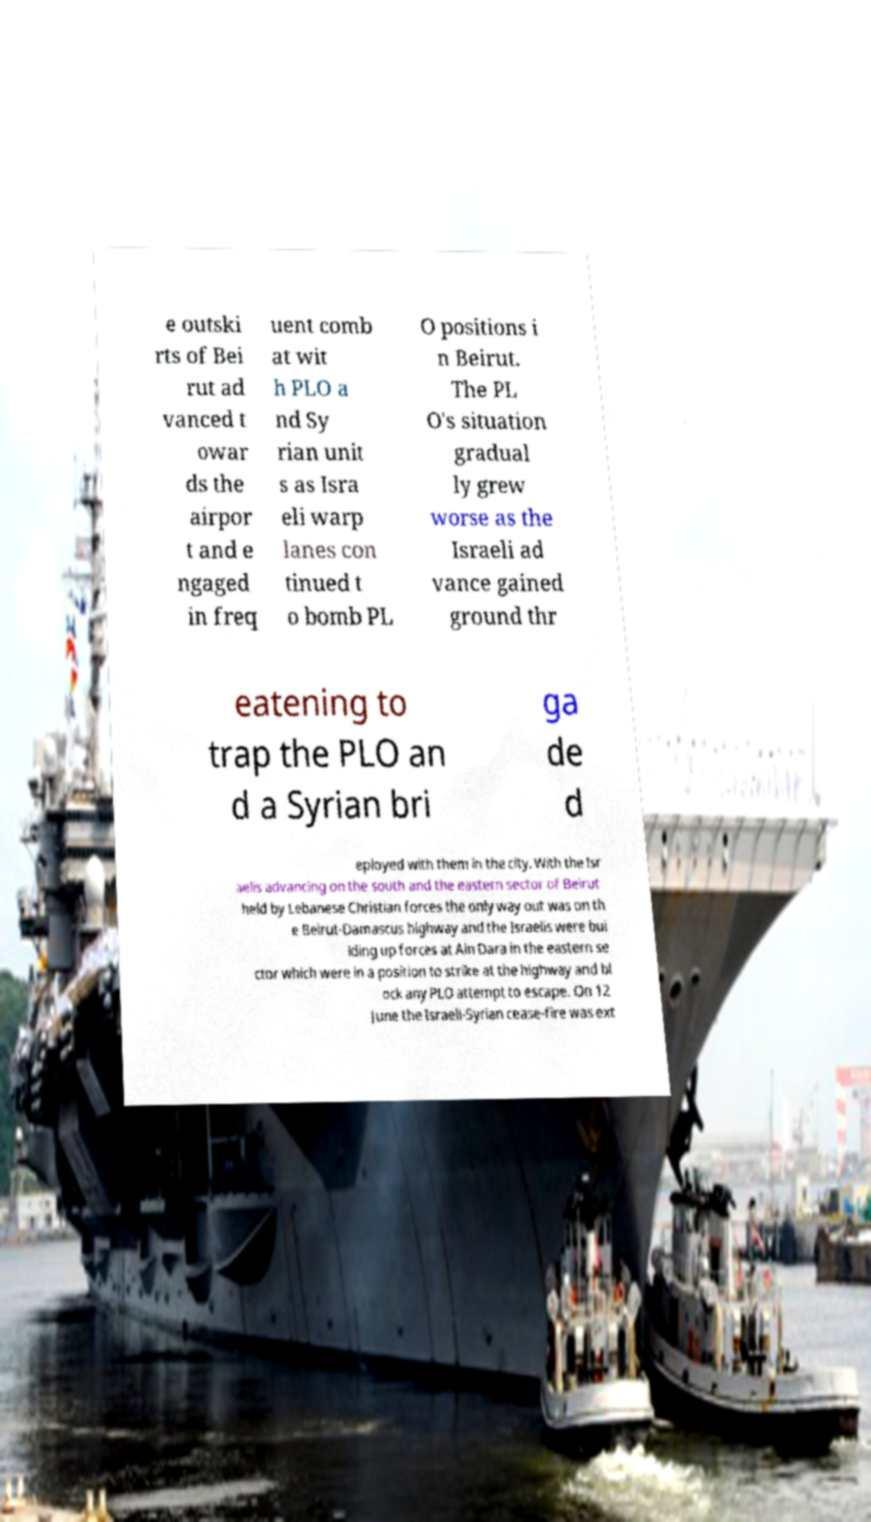Please identify and transcribe the text found in this image. e outski rts of Bei rut ad vanced t owar ds the airpor t and e ngaged in freq uent comb at wit h PLO a nd Sy rian unit s as Isra eli warp lanes con tinued t o bomb PL O positions i n Beirut. The PL O's situation gradual ly grew worse as the Israeli ad vance gained ground thr eatening to trap the PLO an d a Syrian bri ga de d eployed with them in the city. With the Isr aelis advancing on the south and the eastern sector of Beirut held by Lebanese Christian forces the only way out was on th e Beirut-Damascus highway and the Israelis were bui lding up forces at Ain Dara in the eastern se ctor which were in a position to strike at the highway and bl ock any PLO attempt to escape. On 12 June the Israeli-Syrian cease-fire was ext 